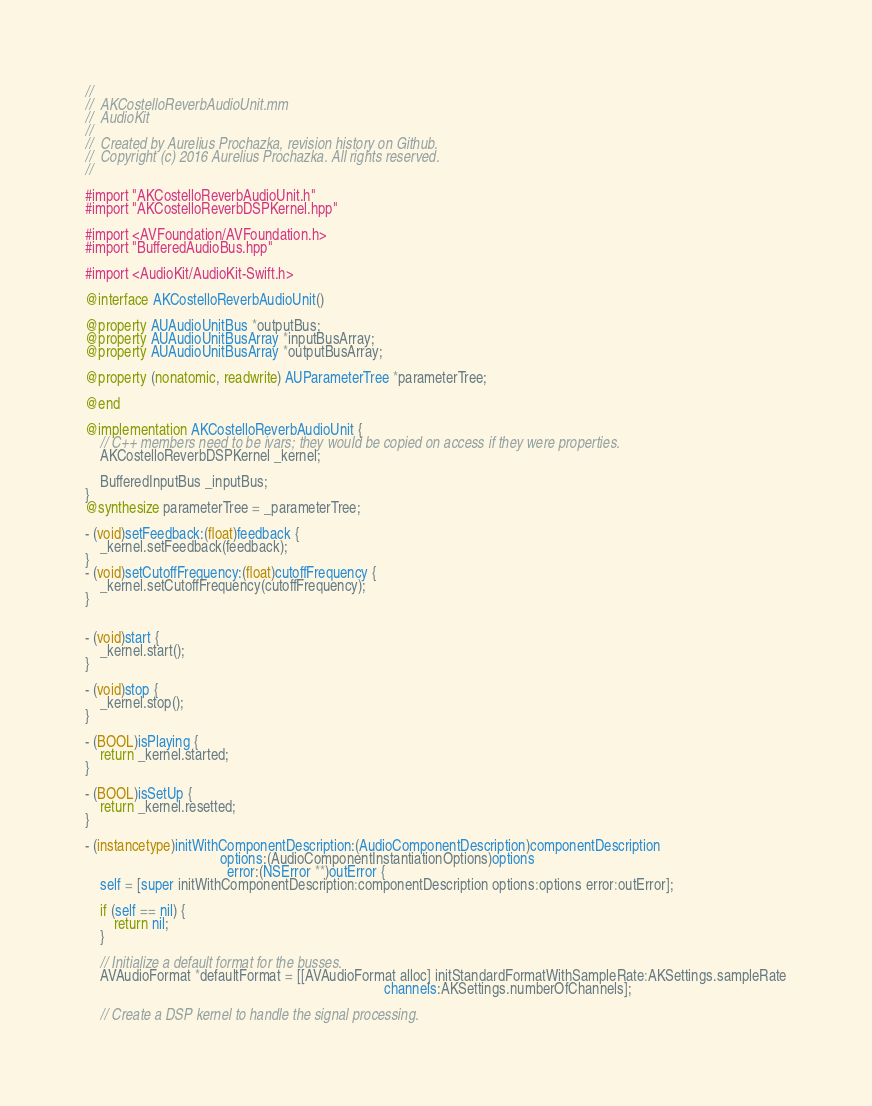Convert code to text. <code><loc_0><loc_0><loc_500><loc_500><_ObjectiveC_>//
//  AKCostelloReverbAudioUnit.mm
//  AudioKit
//
//  Created by Aurelius Prochazka, revision history on Github.
//  Copyright (c) 2016 Aurelius Prochazka. All rights reserved.
//

#import "AKCostelloReverbAudioUnit.h"
#import "AKCostelloReverbDSPKernel.hpp"

#import <AVFoundation/AVFoundation.h>
#import "BufferedAudioBus.hpp"

#import <AudioKit/AudioKit-Swift.h>

@interface AKCostelloReverbAudioUnit()

@property AUAudioUnitBus *outputBus;
@property AUAudioUnitBusArray *inputBusArray;
@property AUAudioUnitBusArray *outputBusArray;

@property (nonatomic, readwrite) AUParameterTree *parameterTree;

@end

@implementation AKCostelloReverbAudioUnit {
    // C++ members need to be ivars; they would be copied on access if they were properties.
    AKCostelloReverbDSPKernel _kernel;

    BufferedInputBus _inputBus;
}
@synthesize parameterTree = _parameterTree;

- (void)setFeedback:(float)feedback {
    _kernel.setFeedback(feedback);
}
- (void)setCutoffFrequency:(float)cutoffFrequency {
    _kernel.setCutoffFrequency(cutoffFrequency);
}


- (void)start {
    _kernel.start();
}

- (void)stop {
    _kernel.stop();
}

- (BOOL)isPlaying {
    return _kernel.started;
}

- (BOOL)isSetUp {
    return _kernel.resetted;
}

- (instancetype)initWithComponentDescription:(AudioComponentDescription)componentDescription
                                     options:(AudioComponentInstantiationOptions)options
                                       error:(NSError **)outError {
    self = [super initWithComponentDescription:componentDescription options:options error:outError];

    if (self == nil) {
        return nil;
    }

    // Initialize a default format for the busses.
    AVAudioFormat *defaultFormat = [[AVAudioFormat alloc] initStandardFormatWithSampleRate:AKSettings.sampleRate
                                                                                  channels:AKSettings.numberOfChannels];

    // Create a DSP kernel to handle the signal processing.</code> 